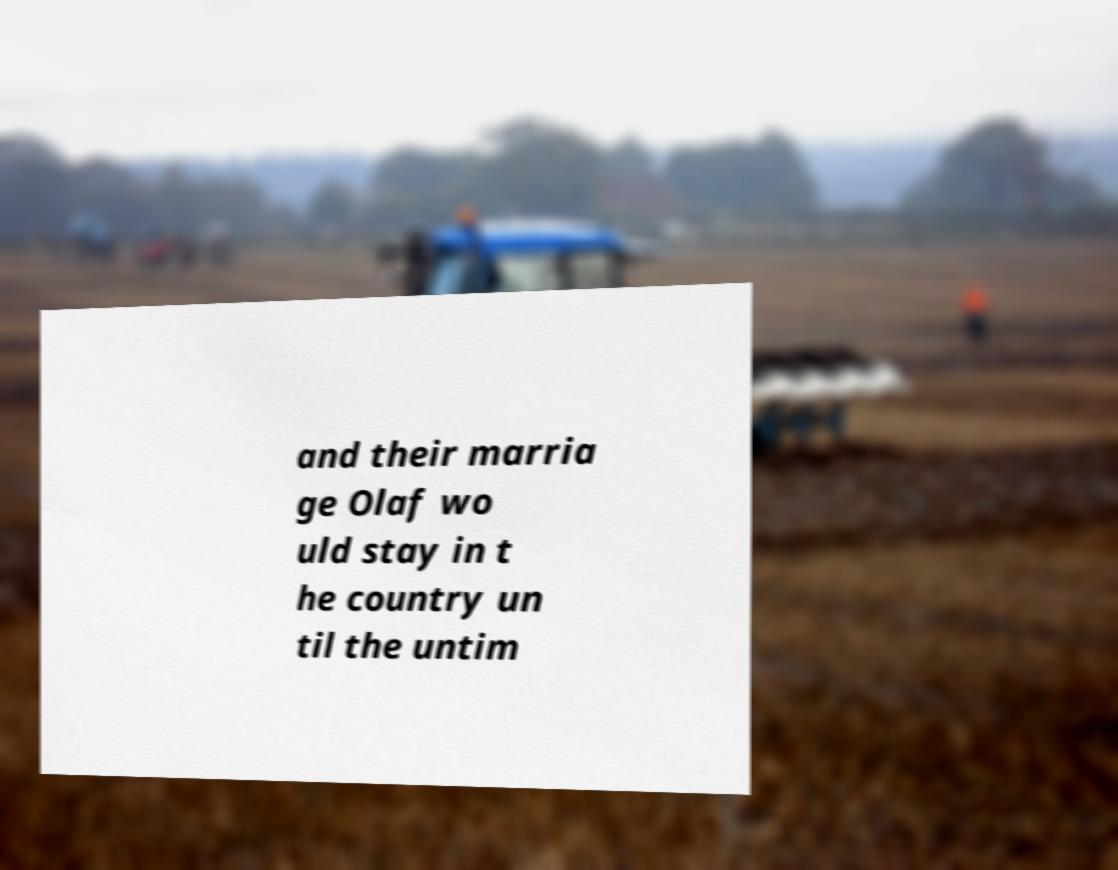Could you assist in decoding the text presented in this image and type it out clearly? and their marria ge Olaf wo uld stay in t he country un til the untim 